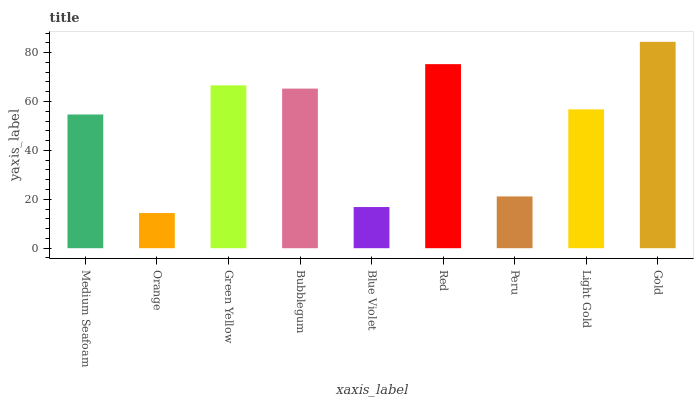Is Orange the minimum?
Answer yes or no. Yes. Is Gold the maximum?
Answer yes or no. Yes. Is Green Yellow the minimum?
Answer yes or no. No. Is Green Yellow the maximum?
Answer yes or no. No. Is Green Yellow greater than Orange?
Answer yes or no. Yes. Is Orange less than Green Yellow?
Answer yes or no. Yes. Is Orange greater than Green Yellow?
Answer yes or no. No. Is Green Yellow less than Orange?
Answer yes or no. No. Is Light Gold the high median?
Answer yes or no. Yes. Is Light Gold the low median?
Answer yes or no. Yes. Is Green Yellow the high median?
Answer yes or no. No. Is Bubblegum the low median?
Answer yes or no. No. 